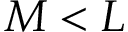Convert formula to latex. <formula><loc_0><loc_0><loc_500><loc_500>M < L</formula> 